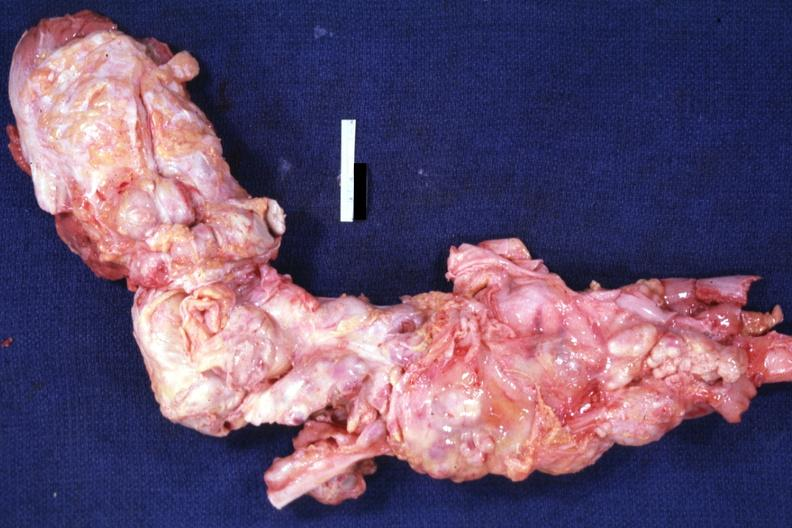s aorta not opened surrounded by large nodes?
Answer the question using a single word or phrase. Yes 